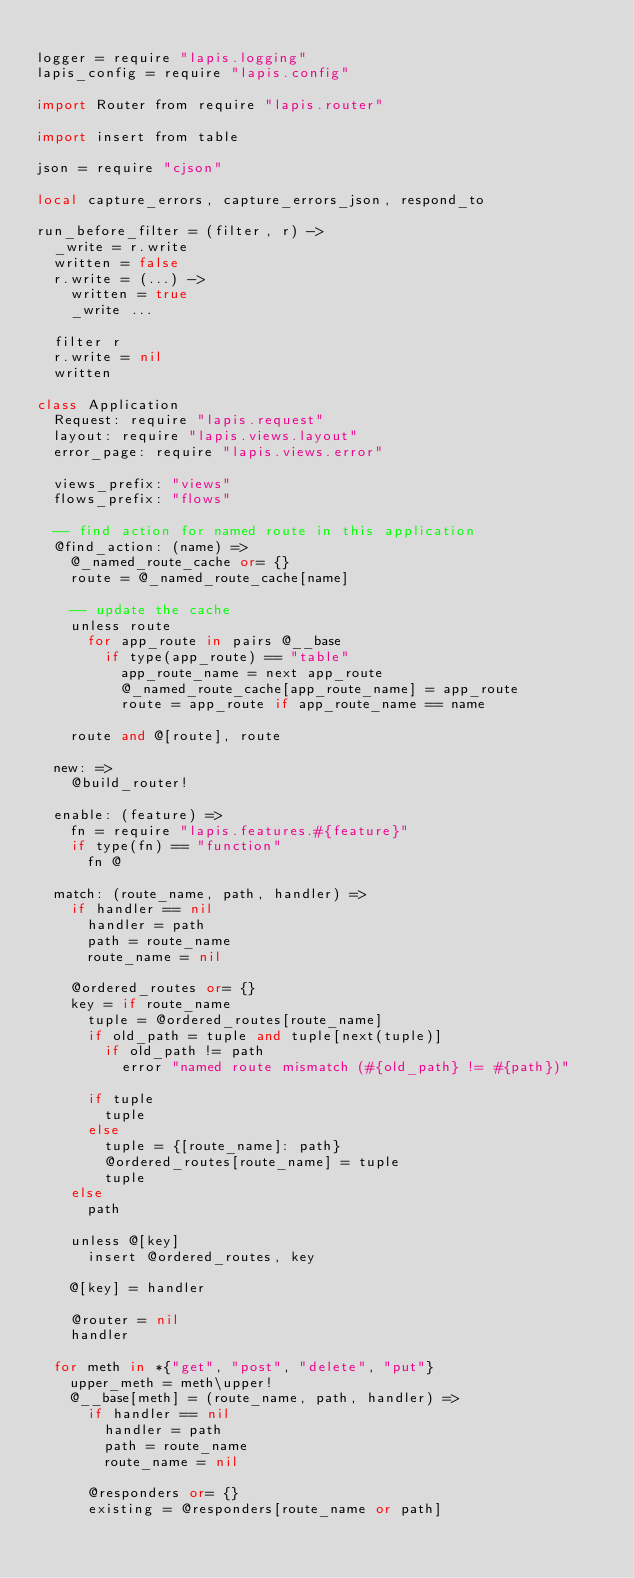Convert code to text. <code><loc_0><loc_0><loc_500><loc_500><_MoonScript_>
logger = require "lapis.logging"
lapis_config = require "lapis.config"

import Router from require "lapis.router"

import insert from table

json = require "cjson"

local capture_errors, capture_errors_json, respond_to

run_before_filter = (filter, r) ->
  _write = r.write
  written = false
  r.write = (...) ->
    written = true
    _write ...

  filter r
  r.write = nil
  written

class Application
  Request: require "lapis.request"
  layout: require "lapis.views.layout"
  error_page: require "lapis.views.error"

  views_prefix: "views"
  flows_prefix: "flows"

  -- find action for named route in this application
  @find_action: (name) =>
    @_named_route_cache or= {}
    route = @_named_route_cache[name]

    -- update the cache
    unless route
      for app_route in pairs @__base
        if type(app_route) == "table"
          app_route_name = next app_route
          @_named_route_cache[app_route_name] = app_route
          route = app_route if app_route_name == name

    route and @[route], route

  new: =>
    @build_router!

  enable: (feature) =>
    fn = require "lapis.features.#{feature}"
    if type(fn) == "function"
      fn @

  match: (route_name, path, handler) =>
    if handler == nil
      handler = path
      path = route_name
      route_name = nil

    @ordered_routes or= {}
    key = if route_name
      tuple = @ordered_routes[route_name]
      if old_path = tuple and tuple[next(tuple)]
        if old_path != path
          error "named route mismatch (#{old_path} != #{path})"

      if tuple
        tuple
      else
        tuple = {[route_name]: path}
        @ordered_routes[route_name] = tuple
        tuple
    else
      path

    unless @[key]
      insert @ordered_routes, key

    @[key] = handler

    @router = nil
    handler

  for meth in *{"get", "post", "delete", "put"}
    upper_meth = meth\upper!
    @__base[meth] = (route_name, path, handler) =>
      if handler == nil
        handler = path
        path = route_name
        route_name = nil

      @responders or= {}
      existing = @responders[route_name or path]</code> 